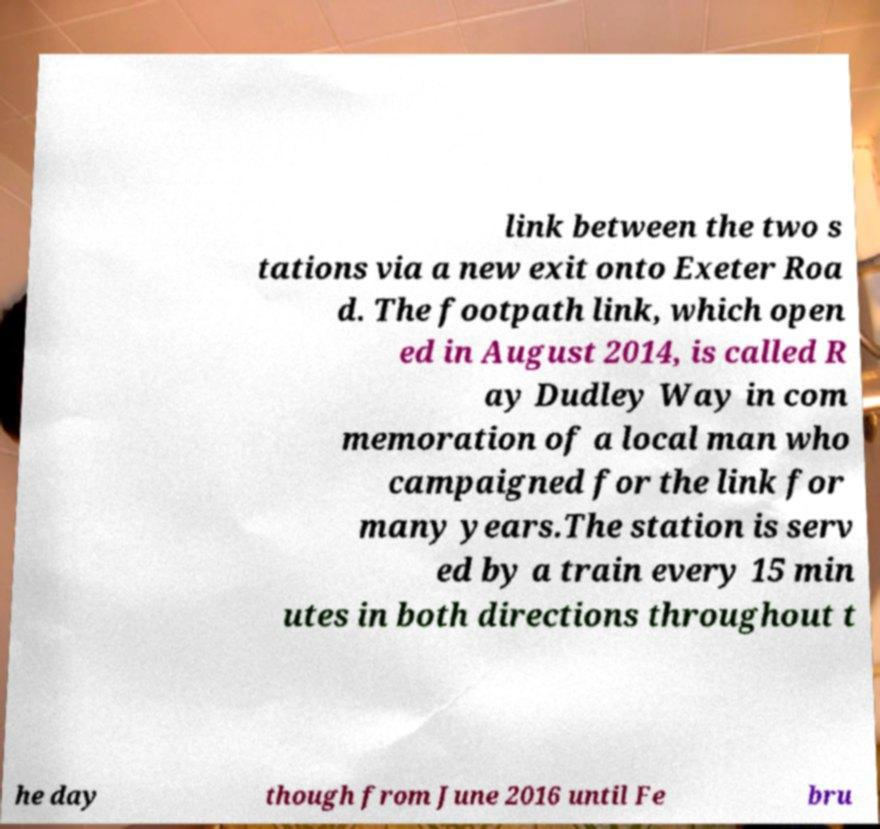For documentation purposes, I need the text within this image transcribed. Could you provide that? link between the two s tations via a new exit onto Exeter Roa d. The footpath link, which open ed in August 2014, is called R ay Dudley Way in com memoration of a local man who campaigned for the link for many years.The station is serv ed by a train every 15 min utes in both directions throughout t he day though from June 2016 until Fe bru 